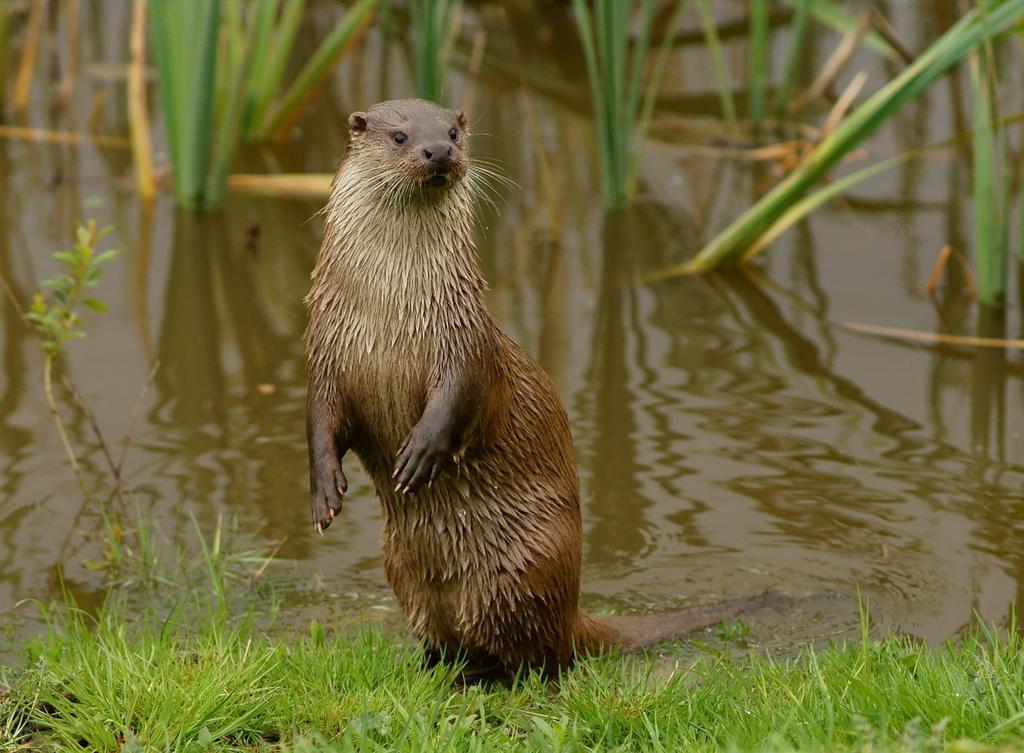Please provide a concise description of this image. Here we can see a sea otter standing on the ground. In the background we can see plants in the water and this is grass at the bottom. 